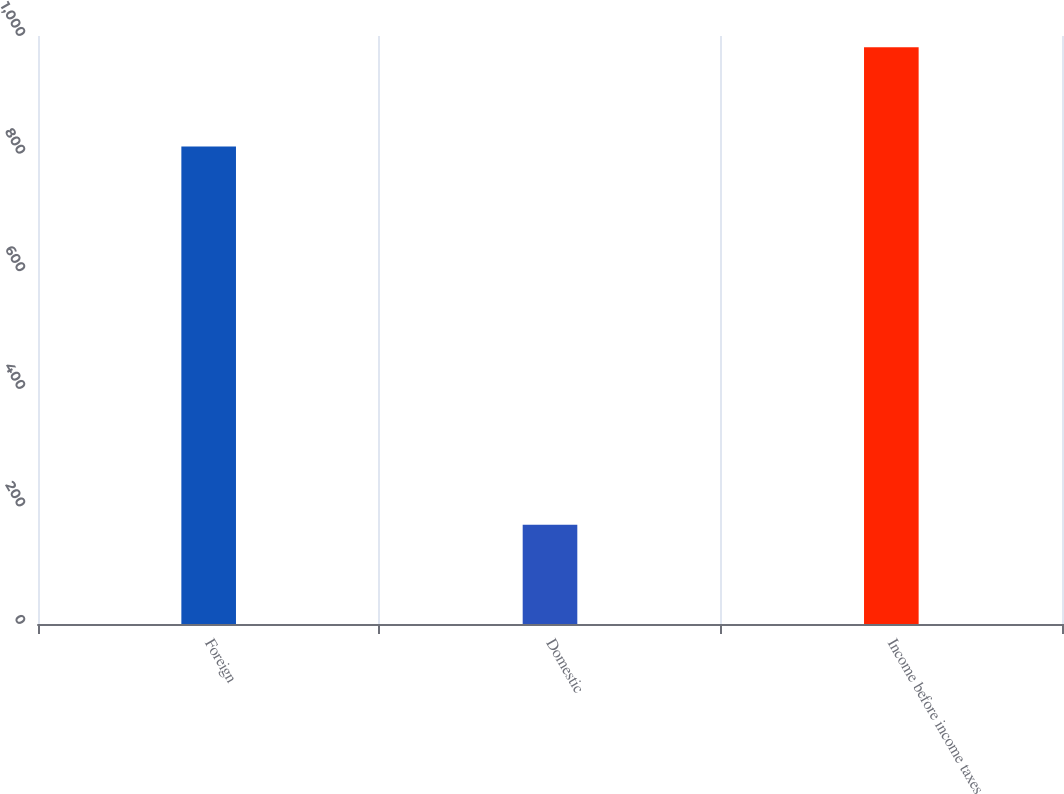Convert chart. <chart><loc_0><loc_0><loc_500><loc_500><bar_chart><fcel>Foreign<fcel>Domestic<fcel>Income before income taxes<nl><fcel>812<fcel>169<fcel>981<nl></chart> 